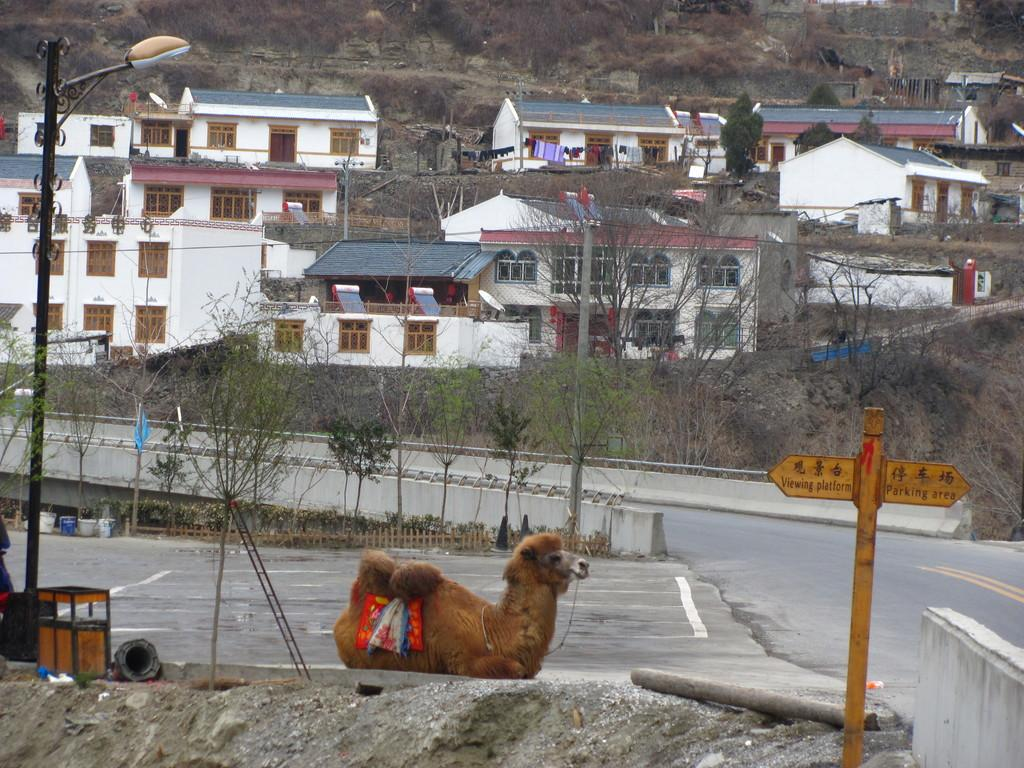What type of structures can be seen in the image? There are buildings in the image. What natural elements are present in the image? There are trees in the image. What type of lighting is present in the image? There is a pole light in the image. What animal is featured in the image? There is a camel in the image. What additional information is provided on the pole light? There is a board with text on the pole light. How does the camel attack the buildings in the image? There is no indication of an attack in the image; the camel is simply present among the buildings. What type of cap is the camel wearing in the image? There is no cap present on the camel in the image. 